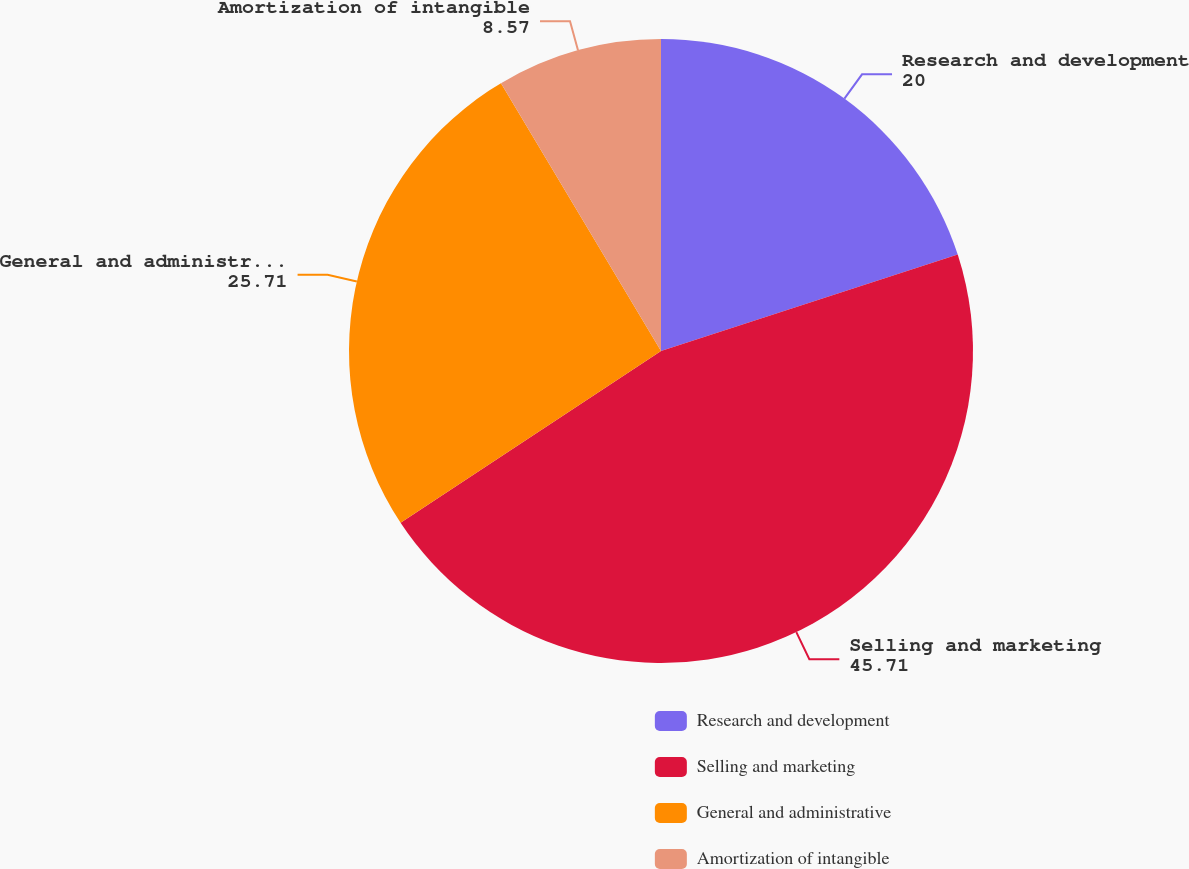Convert chart. <chart><loc_0><loc_0><loc_500><loc_500><pie_chart><fcel>Research and development<fcel>Selling and marketing<fcel>General and administrative<fcel>Amortization of intangible<nl><fcel>20.0%<fcel>45.71%<fcel>25.71%<fcel>8.57%<nl></chart> 